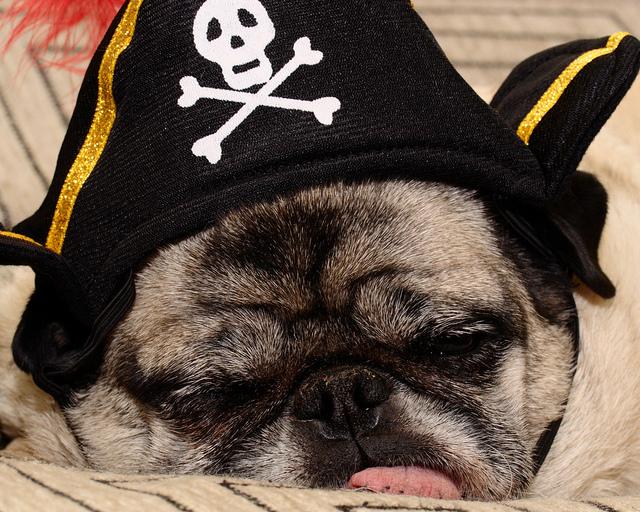Is the dog a pirate?
Quick response, please. Yes. Would anyone think that this dog is a terror of the high seas?
Give a very brief answer. No. What color is the dog?
Give a very brief answer. Brown. Is this dog sleeping?
Quick response, please. Yes. Does this dog realizing it is wearing a hat?
Short answer required. No. 